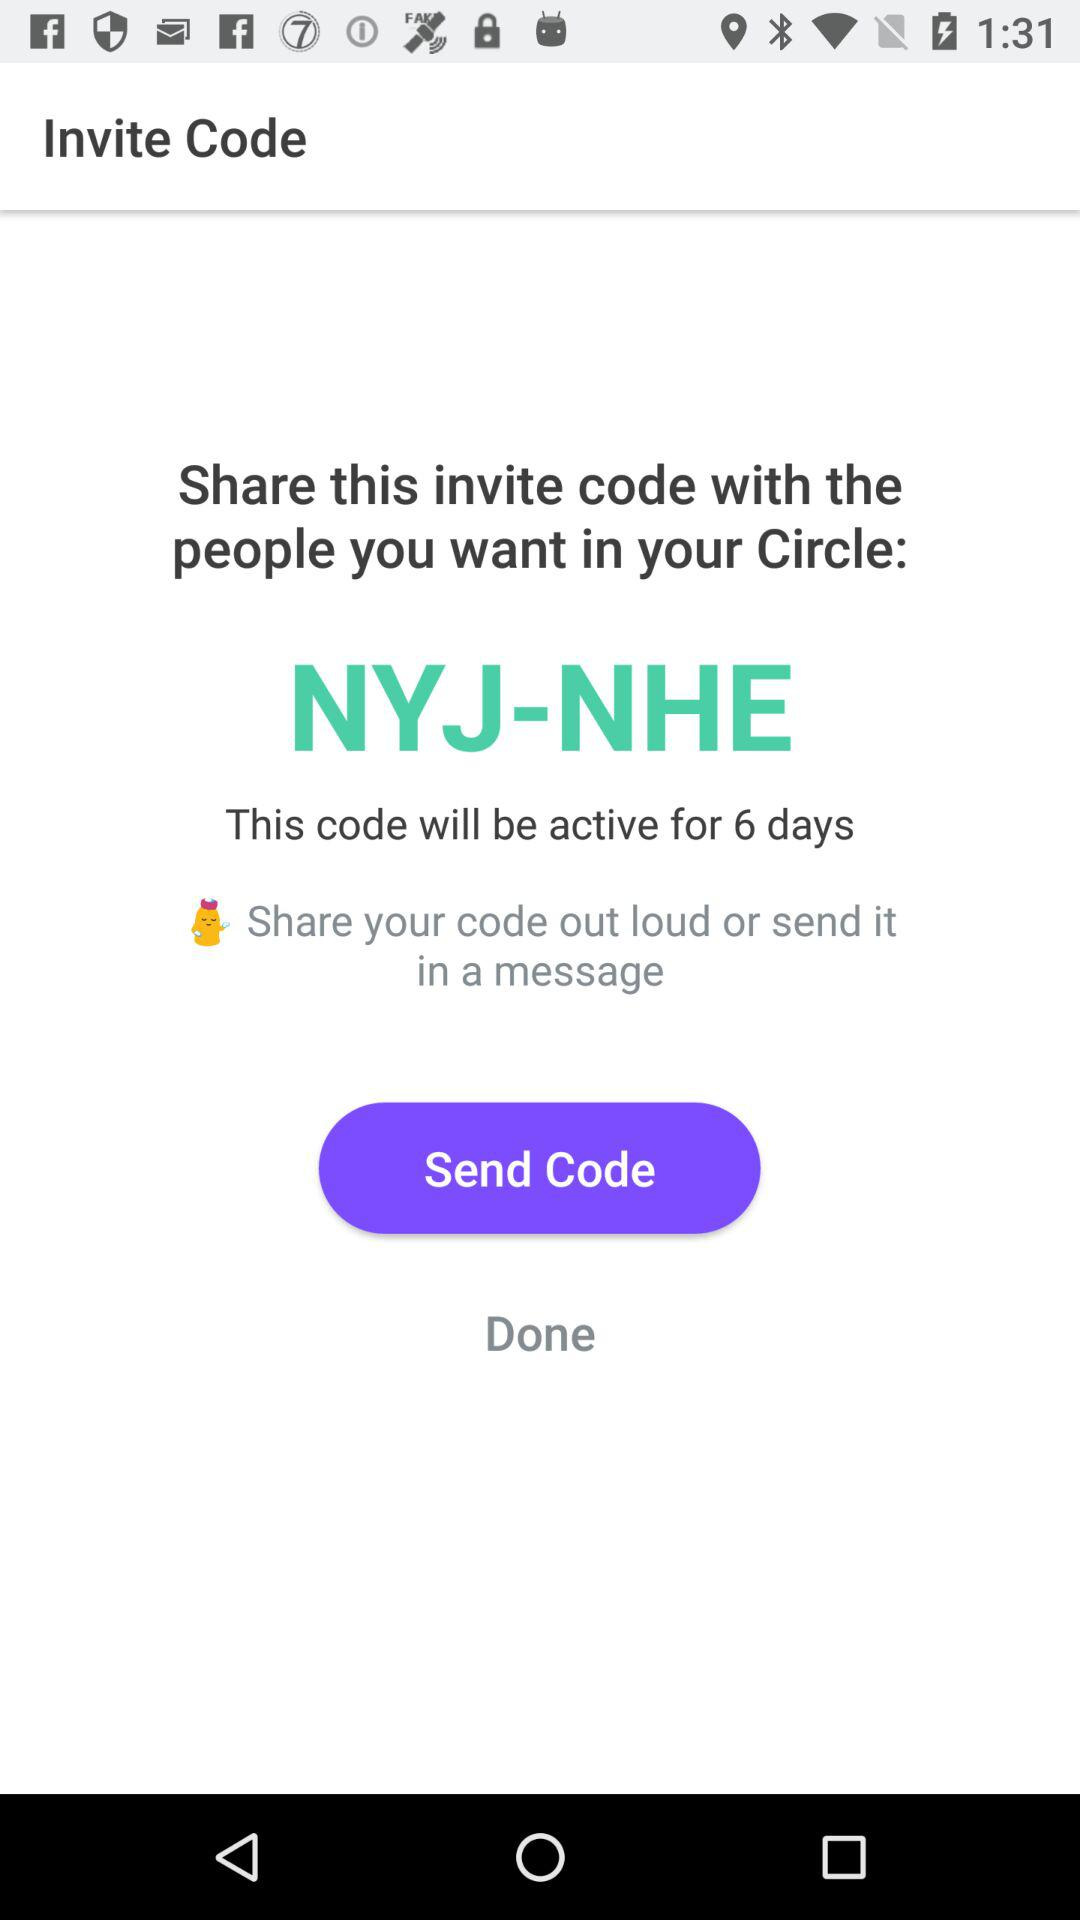What is the invite code? The invite code is NYJ-NHE. 